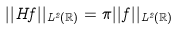Convert formula to latex. <formula><loc_0><loc_0><loc_500><loc_500>| | H f | | _ { L ^ { 2 } ( \mathbb { R } ) } = \pi | | f | | _ { L ^ { 2 } ( \mathbb { R } ) }</formula> 